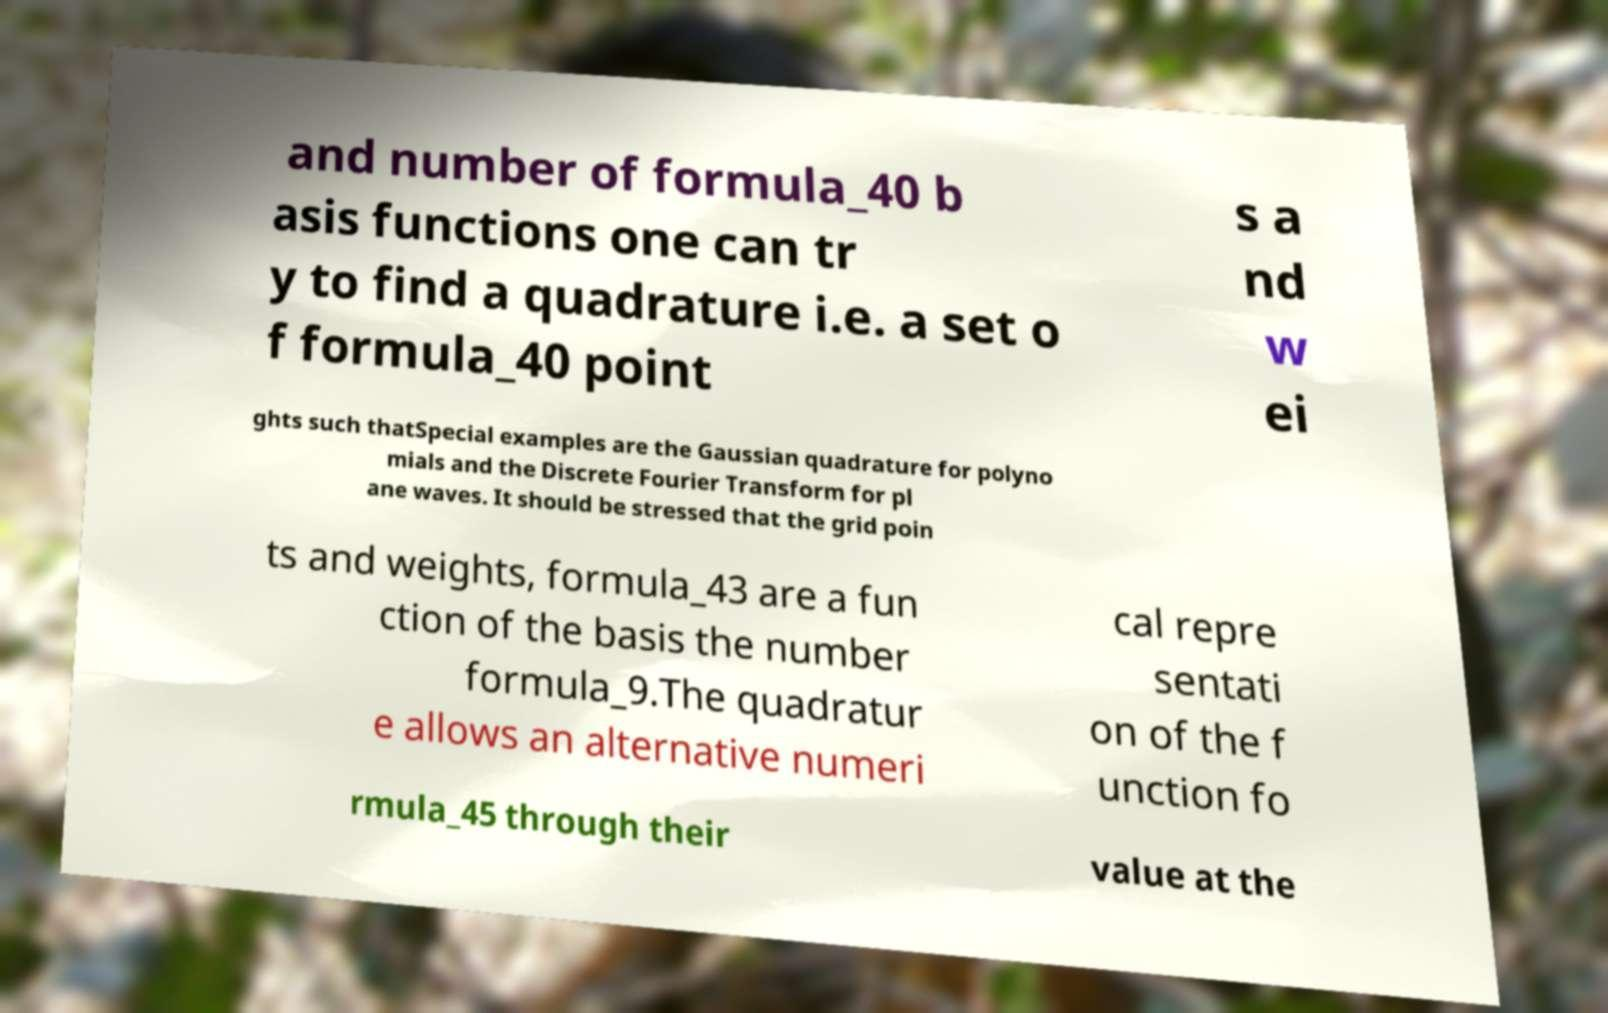Please read and relay the text visible in this image. What does it say? and number of formula_40 b asis functions one can tr y to find a quadrature i.e. a set o f formula_40 point s a nd w ei ghts such thatSpecial examples are the Gaussian quadrature for polyno mials and the Discrete Fourier Transform for pl ane waves. It should be stressed that the grid poin ts and weights, formula_43 are a fun ction of the basis the number formula_9.The quadratur e allows an alternative numeri cal repre sentati on of the f unction fo rmula_45 through their value at the 